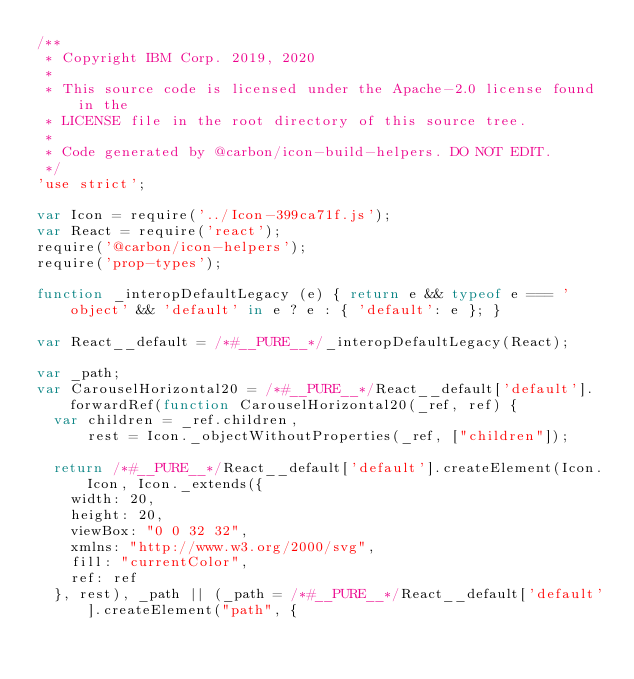<code> <loc_0><loc_0><loc_500><loc_500><_JavaScript_>/**
 * Copyright IBM Corp. 2019, 2020
 *
 * This source code is licensed under the Apache-2.0 license found in the
 * LICENSE file in the root directory of this source tree.
 *
 * Code generated by @carbon/icon-build-helpers. DO NOT EDIT.
 */
'use strict';

var Icon = require('../Icon-399ca71f.js');
var React = require('react');
require('@carbon/icon-helpers');
require('prop-types');

function _interopDefaultLegacy (e) { return e && typeof e === 'object' && 'default' in e ? e : { 'default': e }; }

var React__default = /*#__PURE__*/_interopDefaultLegacy(React);

var _path;
var CarouselHorizontal20 = /*#__PURE__*/React__default['default'].forwardRef(function CarouselHorizontal20(_ref, ref) {
  var children = _ref.children,
      rest = Icon._objectWithoutProperties(_ref, ["children"]);

  return /*#__PURE__*/React__default['default'].createElement(Icon.Icon, Icon._extends({
    width: 20,
    height: 20,
    viewBox: "0 0 32 32",
    xmlns: "http://www.w3.org/2000/svg",
    fill: "currentColor",
    ref: ref
  }, rest), _path || (_path = /*#__PURE__*/React__default['default'].createElement("path", {</code> 